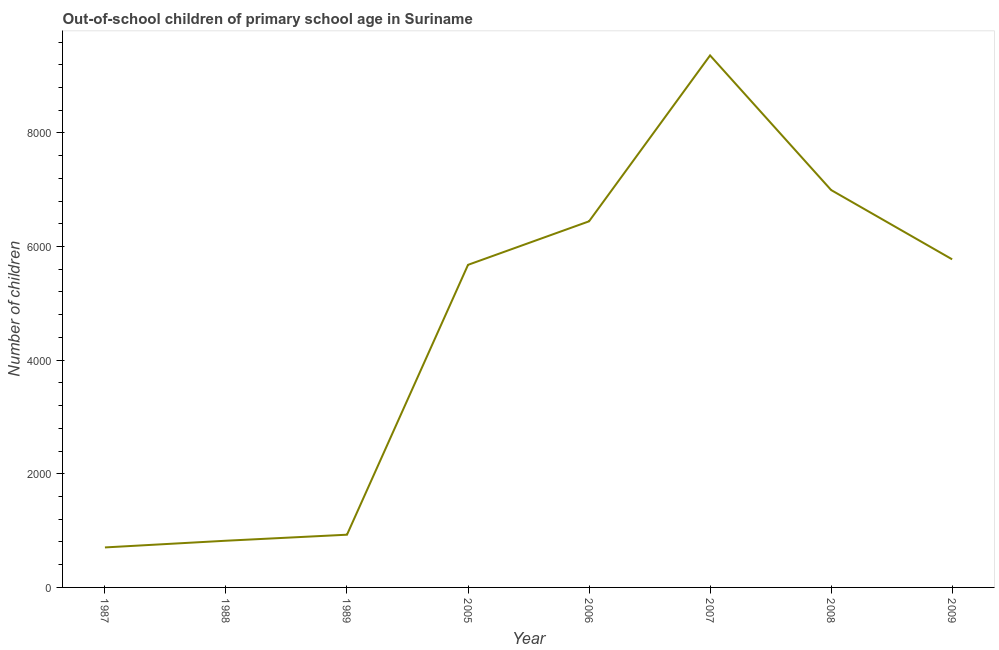What is the number of out-of-school children in 1989?
Your answer should be compact. 928. Across all years, what is the maximum number of out-of-school children?
Your response must be concise. 9364. Across all years, what is the minimum number of out-of-school children?
Provide a short and direct response. 704. What is the sum of the number of out-of-school children?
Your response must be concise. 3.67e+04. What is the difference between the number of out-of-school children in 2008 and 2009?
Ensure brevity in your answer.  1220. What is the average number of out-of-school children per year?
Give a very brief answer. 4588.75. What is the median number of out-of-school children?
Provide a short and direct response. 5726.5. Do a majority of the years between 2009 and 1989 (inclusive) have number of out-of-school children greater than 8400 ?
Keep it short and to the point. Yes. What is the ratio of the number of out-of-school children in 2007 to that in 2008?
Keep it short and to the point. 1.34. Is the difference between the number of out-of-school children in 2005 and 2006 greater than the difference between any two years?
Your response must be concise. No. What is the difference between the highest and the second highest number of out-of-school children?
Keep it short and to the point. 2369. Is the sum of the number of out-of-school children in 1987 and 2005 greater than the maximum number of out-of-school children across all years?
Your answer should be very brief. No. What is the difference between the highest and the lowest number of out-of-school children?
Provide a succinct answer. 8660. In how many years, is the number of out-of-school children greater than the average number of out-of-school children taken over all years?
Offer a terse response. 5. How many lines are there?
Your answer should be very brief. 1. How many years are there in the graph?
Keep it short and to the point. 8. Does the graph contain any zero values?
Offer a very short reply. No. Does the graph contain grids?
Give a very brief answer. No. What is the title of the graph?
Your response must be concise. Out-of-school children of primary school age in Suriname. What is the label or title of the X-axis?
Give a very brief answer. Year. What is the label or title of the Y-axis?
Ensure brevity in your answer.  Number of children. What is the Number of children in 1987?
Offer a very short reply. 704. What is the Number of children in 1988?
Provide a succinct answer. 822. What is the Number of children in 1989?
Your response must be concise. 928. What is the Number of children in 2005?
Keep it short and to the point. 5678. What is the Number of children in 2006?
Offer a very short reply. 6444. What is the Number of children in 2007?
Your answer should be very brief. 9364. What is the Number of children in 2008?
Keep it short and to the point. 6995. What is the Number of children of 2009?
Give a very brief answer. 5775. What is the difference between the Number of children in 1987 and 1988?
Your response must be concise. -118. What is the difference between the Number of children in 1987 and 1989?
Offer a terse response. -224. What is the difference between the Number of children in 1987 and 2005?
Give a very brief answer. -4974. What is the difference between the Number of children in 1987 and 2006?
Your response must be concise. -5740. What is the difference between the Number of children in 1987 and 2007?
Offer a very short reply. -8660. What is the difference between the Number of children in 1987 and 2008?
Your answer should be compact. -6291. What is the difference between the Number of children in 1987 and 2009?
Your response must be concise. -5071. What is the difference between the Number of children in 1988 and 1989?
Offer a very short reply. -106. What is the difference between the Number of children in 1988 and 2005?
Make the answer very short. -4856. What is the difference between the Number of children in 1988 and 2006?
Keep it short and to the point. -5622. What is the difference between the Number of children in 1988 and 2007?
Offer a very short reply. -8542. What is the difference between the Number of children in 1988 and 2008?
Provide a short and direct response. -6173. What is the difference between the Number of children in 1988 and 2009?
Provide a short and direct response. -4953. What is the difference between the Number of children in 1989 and 2005?
Make the answer very short. -4750. What is the difference between the Number of children in 1989 and 2006?
Offer a very short reply. -5516. What is the difference between the Number of children in 1989 and 2007?
Offer a very short reply. -8436. What is the difference between the Number of children in 1989 and 2008?
Provide a short and direct response. -6067. What is the difference between the Number of children in 1989 and 2009?
Your answer should be compact. -4847. What is the difference between the Number of children in 2005 and 2006?
Provide a short and direct response. -766. What is the difference between the Number of children in 2005 and 2007?
Your answer should be very brief. -3686. What is the difference between the Number of children in 2005 and 2008?
Provide a short and direct response. -1317. What is the difference between the Number of children in 2005 and 2009?
Your answer should be compact. -97. What is the difference between the Number of children in 2006 and 2007?
Provide a succinct answer. -2920. What is the difference between the Number of children in 2006 and 2008?
Provide a short and direct response. -551. What is the difference between the Number of children in 2006 and 2009?
Provide a succinct answer. 669. What is the difference between the Number of children in 2007 and 2008?
Ensure brevity in your answer.  2369. What is the difference between the Number of children in 2007 and 2009?
Your answer should be compact. 3589. What is the difference between the Number of children in 2008 and 2009?
Your response must be concise. 1220. What is the ratio of the Number of children in 1987 to that in 1988?
Your response must be concise. 0.86. What is the ratio of the Number of children in 1987 to that in 1989?
Keep it short and to the point. 0.76. What is the ratio of the Number of children in 1987 to that in 2005?
Ensure brevity in your answer.  0.12. What is the ratio of the Number of children in 1987 to that in 2006?
Keep it short and to the point. 0.11. What is the ratio of the Number of children in 1987 to that in 2007?
Your answer should be compact. 0.07. What is the ratio of the Number of children in 1987 to that in 2008?
Offer a terse response. 0.1. What is the ratio of the Number of children in 1987 to that in 2009?
Offer a very short reply. 0.12. What is the ratio of the Number of children in 1988 to that in 1989?
Provide a short and direct response. 0.89. What is the ratio of the Number of children in 1988 to that in 2005?
Offer a terse response. 0.14. What is the ratio of the Number of children in 1988 to that in 2006?
Provide a succinct answer. 0.13. What is the ratio of the Number of children in 1988 to that in 2007?
Your response must be concise. 0.09. What is the ratio of the Number of children in 1988 to that in 2008?
Your answer should be compact. 0.12. What is the ratio of the Number of children in 1988 to that in 2009?
Your response must be concise. 0.14. What is the ratio of the Number of children in 1989 to that in 2005?
Provide a succinct answer. 0.16. What is the ratio of the Number of children in 1989 to that in 2006?
Provide a short and direct response. 0.14. What is the ratio of the Number of children in 1989 to that in 2007?
Keep it short and to the point. 0.1. What is the ratio of the Number of children in 1989 to that in 2008?
Your response must be concise. 0.13. What is the ratio of the Number of children in 1989 to that in 2009?
Ensure brevity in your answer.  0.16. What is the ratio of the Number of children in 2005 to that in 2006?
Your answer should be very brief. 0.88. What is the ratio of the Number of children in 2005 to that in 2007?
Keep it short and to the point. 0.61. What is the ratio of the Number of children in 2005 to that in 2008?
Ensure brevity in your answer.  0.81. What is the ratio of the Number of children in 2006 to that in 2007?
Your response must be concise. 0.69. What is the ratio of the Number of children in 2006 to that in 2008?
Provide a succinct answer. 0.92. What is the ratio of the Number of children in 2006 to that in 2009?
Keep it short and to the point. 1.12. What is the ratio of the Number of children in 2007 to that in 2008?
Provide a succinct answer. 1.34. What is the ratio of the Number of children in 2007 to that in 2009?
Make the answer very short. 1.62. What is the ratio of the Number of children in 2008 to that in 2009?
Your response must be concise. 1.21. 